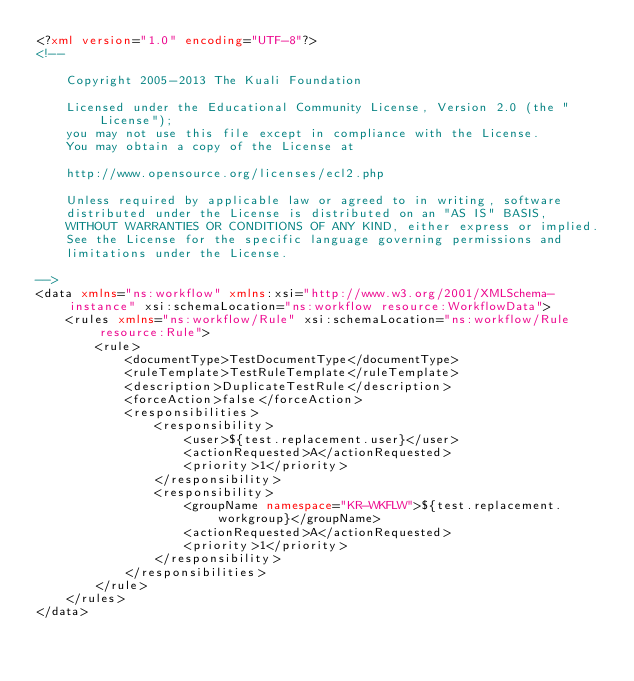Convert code to text. <code><loc_0><loc_0><loc_500><loc_500><_XML_><?xml version="1.0" encoding="UTF-8"?>
<!--

    Copyright 2005-2013 The Kuali Foundation

    Licensed under the Educational Community License, Version 2.0 (the "License");
    you may not use this file except in compliance with the License.
    You may obtain a copy of the License at

    http://www.opensource.org/licenses/ecl2.php

    Unless required by applicable law or agreed to in writing, software
    distributed under the License is distributed on an "AS IS" BASIS,
    WITHOUT WARRANTIES OR CONDITIONS OF ANY KIND, either express or implied.
    See the License for the specific language governing permissions and
    limitations under the License.

-->
<data xmlns="ns:workflow" xmlns:xsi="http://www.w3.org/2001/XMLSchema-instance" xsi:schemaLocation="ns:workflow resource:WorkflowData">
    <rules xmlns="ns:workflow/Rule" xsi:schemaLocation="ns:workflow/Rule resource:Rule">
        <rule>
            <documentType>TestDocumentType</documentType>
            <ruleTemplate>TestRuleTemplate</ruleTemplate>
            <description>DuplicateTestRule</description>
            <forceAction>false</forceAction>
            <responsibilities>
                <responsibility>
                    <user>${test.replacement.user}</user>
                    <actionRequested>A</actionRequested>
                    <priority>1</priority>
                </responsibility>
                <responsibility>
                    <groupName namespace="KR-WKFLW">${test.replacement.workgroup}</groupName>
                    <actionRequested>A</actionRequested>
                    <priority>1</priority>
                </responsibility>
            </responsibilities>
        </rule>
    </rules>
</data>
</code> 